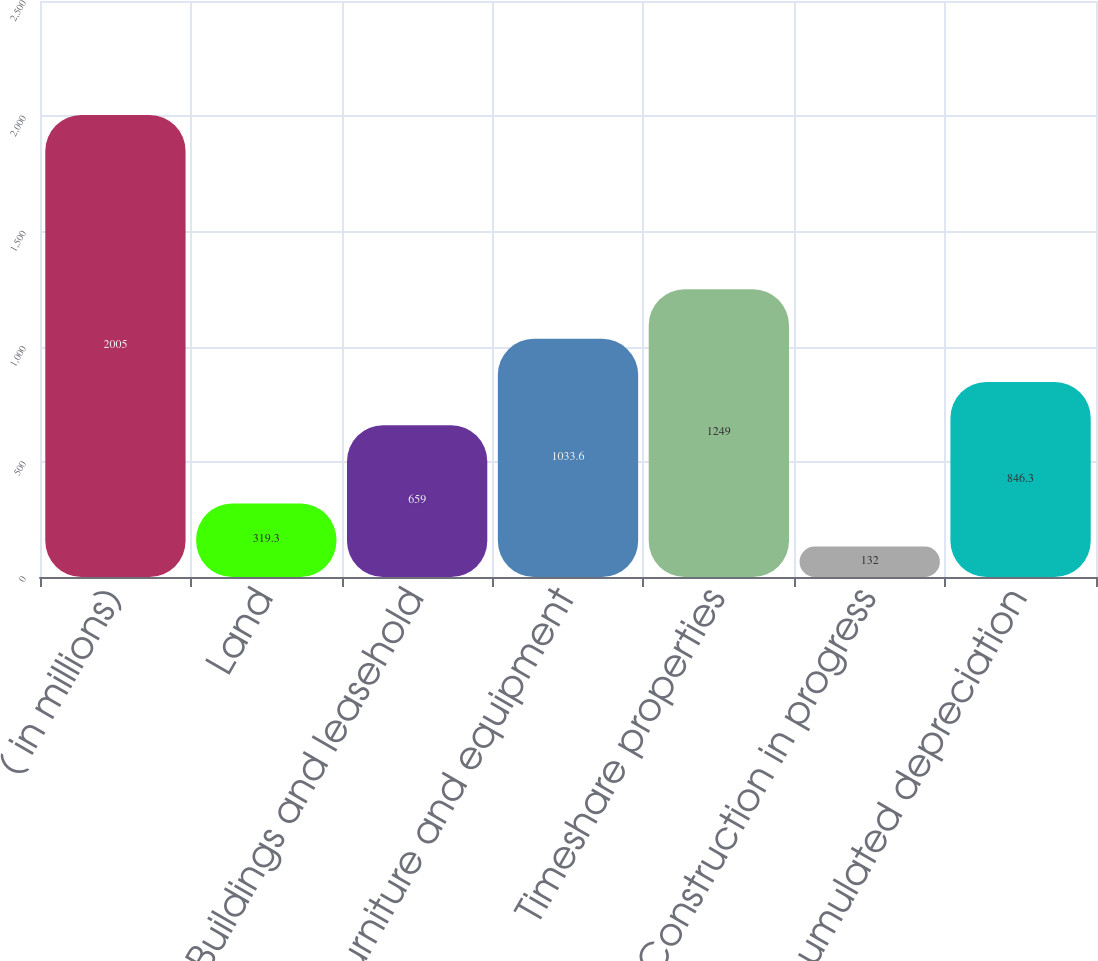Convert chart to OTSL. <chart><loc_0><loc_0><loc_500><loc_500><bar_chart><fcel>( in millions)<fcel>Land<fcel>Buildings and leasehold<fcel>Furniture and equipment<fcel>Timeshare properties<fcel>Construction in progress<fcel>Accumulated depreciation<nl><fcel>2005<fcel>319.3<fcel>659<fcel>1033.6<fcel>1249<fcel>132<fcel>846.3<nl></chart> 